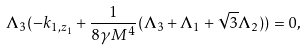<formula> <loc_0><loc_0><loc_500><loc_500>\Lambda _ { 3 } ( - k _ { 1 , z _ { 1 } } + \frac { 1 } { 8 \gamma M ^ { 4 } } ( \Lambda _ { 3 } + \Lambda _ { 1 } + \sqrt { 3 } \Lambda _ { 2 } ) ) = 0 ,</formula> 